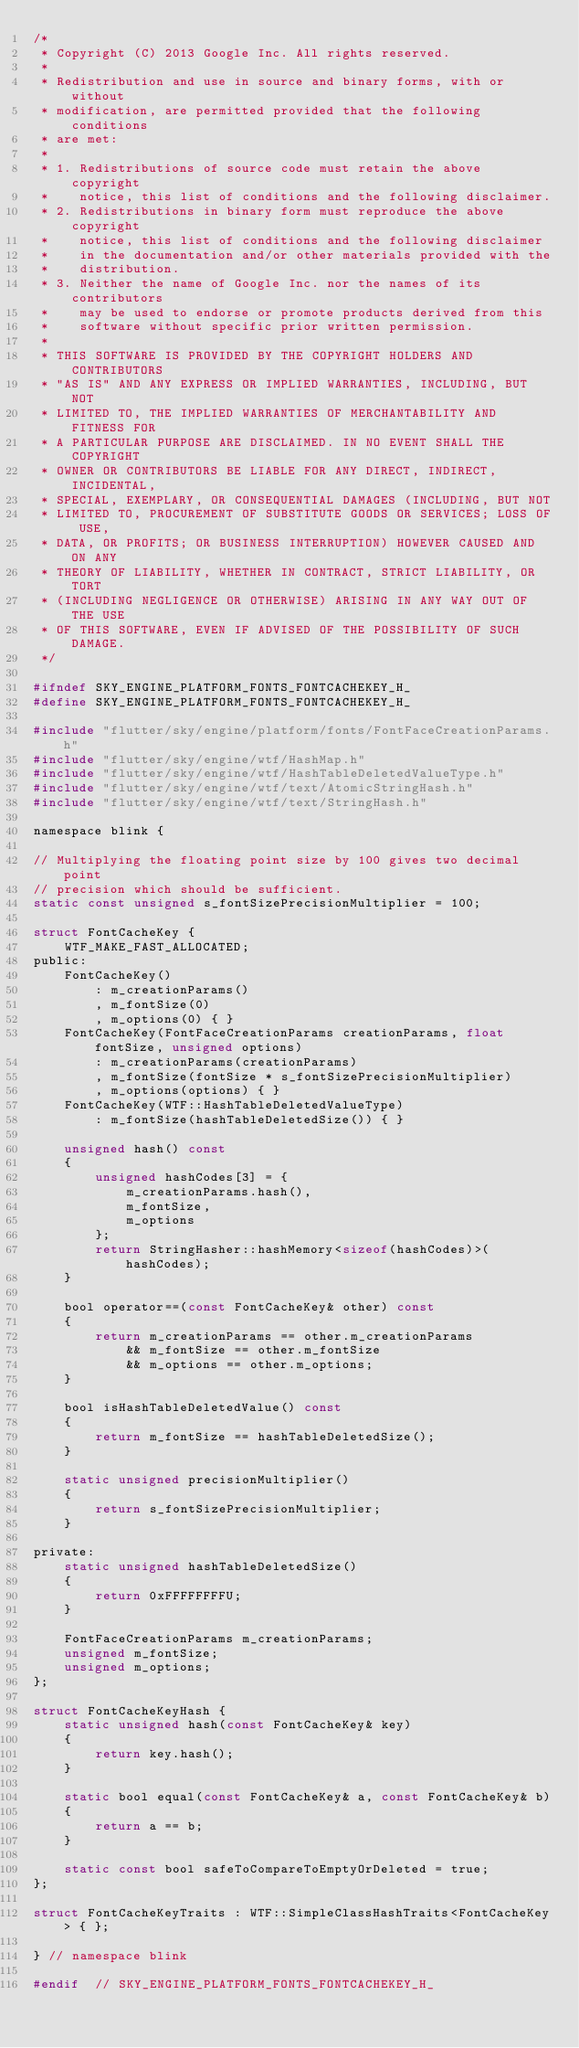Convert code to text. <code><loc_0><loc_0><loc_500><loc_500><_C_>/*
 * Copyright (C) 2013 Google Inc. All rights reserved.
 *
 * Redistribution and use in source and binary forms, with or without
 * modification, are permitted provided that the following conditions
 * are met:
 *
 * 1. Redistributions of source code must retain the above copyright
 *    notice, this list of conditions and the following disclaimer.
 * 2. Redistributions in binary form must reproduce the above copyright
 *    notice, this list of conditions and the following disclaimer
 *    in the documentation and/or other materials provided with the
 *    distribution.
 * 3. Neither the name of Google Inc. nor the names of its contributors
 *    may be used to endorse or promote products derived from this
 *    software without specific prior written permission.
 *
 * THIS SOFTWARE IS PROVIDED BY THE COPYRIGHT HOLDERS AND CONTRIBUTORS
 * "AS IS" AND ANY EXPRESS OR IMPLIED WARRANTIES, INCLUDING, BUT NOT
 * LIMITED TO, THE IMPLIED WARRANTIES OF MERCHANTABILITY AND FITNESS FOR
 * A PARTICULAR PURPOSE ARE DISCLAIMED. IN NO EVENT SHALL THE COPYRIGHT
 * OWNER OR CONTRIBUTORS BE LIABLE FOR ANY DIRECT, INDIRECT, INCIDENTAL,
 * SPECIAL, EXEMPLARY, OR CONSEQUENTIAL DAMAGES (INCLUDING, BUT NOT
 * LIMITED TO, PROCUREMENT OF SUBSTITUTE GOODS OR SERVICES; LOSS OF USE,
 * DATA, OR PROFITS; OR BUSINESS INTERRUPTION) HOWEVER CAUSED AND ON ANY
 * THEORY OF LIABILITY, WHETHER IN CONTRACT, STRICT LIABILITY, OR TORT
 * (INCLUDING NEGLIGENCE OR OTHERWISE) ARISING IN ANY WAY OUT OF THE USE
 * OF THIS SOFTWARE, EVEN IF ADVISED OF THE POSSIBILITY OF SUCH DAMAGE.
 */

#ifndef SKY_ENGINE_PLATFORM_FONTS_FONTCACHEKEY_H_
#define SKY_ENGINE_PLATFORM_FONTS_FONTCACHEKEY_H_

#include "flutter/sky/engine/platform/fonts/FontFaceCreationParams.h"
#include "flutter/sky/engine/wtf/HashMap.h"
#include "flutter/sky/engine/wtf/HashTableDeletedValueType.h"
#include "flutter/sky/engine/wtf/text/AtomicStringHash.h"
#include "flutter/sky/engine/wtf/text/StringHash.h"

namespace blink {

// Multiplying the floating point size by 100 gives two decimal point
// precision which should be sufficient.
static const unsigned s_fontSizePrecisionMultiplier = 100;

struct FontCacheKey {
    WTF_MAKE_FAST_ALLOCATED;
public:
    FontCacheKey()
        : m_creationParams()
        , m_fontSize(0)
        , m_options(0) { }
    FontCacheKey(FontFaceCreationParams creationParams, float fontSize, unsigned options)
        : m_creationParams(creationParams)
        , m_fontSize(fontSize * s_fontSizePrecisionMultiplier)
        , m_options(options) { }
    FontCacheKey(WTF::HashTableDeletedValueType)
        : m_fontSize(hashTableDeletedSize()) { }

    unsigned hash() const
    {
        unsigned hashCodes[3] = {
            m_creationParams.hash(),
            m_fontSize,
            m_options
        };
        return StringHasher::hashMemory<sizeof(hashCodes)>(hashCodes);
    }

    bool operator==(const FontCacheKey& other) const
    {
        return m_creationParams == other.m_creationParams
            && m_fontSize == other.m_fontSize
            && m_options == other.m_options;
    }

    bool isHashTableDeletedValue() const
    {
        return m_fontSize == hashTableDeletedSize();
    }

    static unsigned precisionMultiplier()
    {
        return s_fontSizePrecisionMultiplier;
    }

private:
    static unsigned hashTableDeletedSize()
    {
        return 0xFFFFFFFFU;
    }

    FontFaceCreationParams m_creationParams;
    unsigned m_fontSize;
    unsigned m_options;
};

struct FontCacheKeyHash {
    static unsigned hash(const FontCacheKey& key)
    {
        return key.hash();
    }

    static bool equal(const FontCacheKey& a, const FontCacheKey& b)
    {
        return a == b;
    }

    static const bool safeToCompareToEmptyOrDeleted = true;
};

struct FontCacheKeyTraits : WTF::SimpleClassHashTraits<FontCacheKey> { };

} // namespace blink

#endif  // SKY_ENGINE_PLATFORM_FONTS_FONTCACHEKEY_H_
</code> 